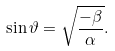<formula> <loc_0><loc_0><loc_500><loc_500>\sin \vartheta = \sqrt { \frac { - \beta } { \alpha } } .</formula> 